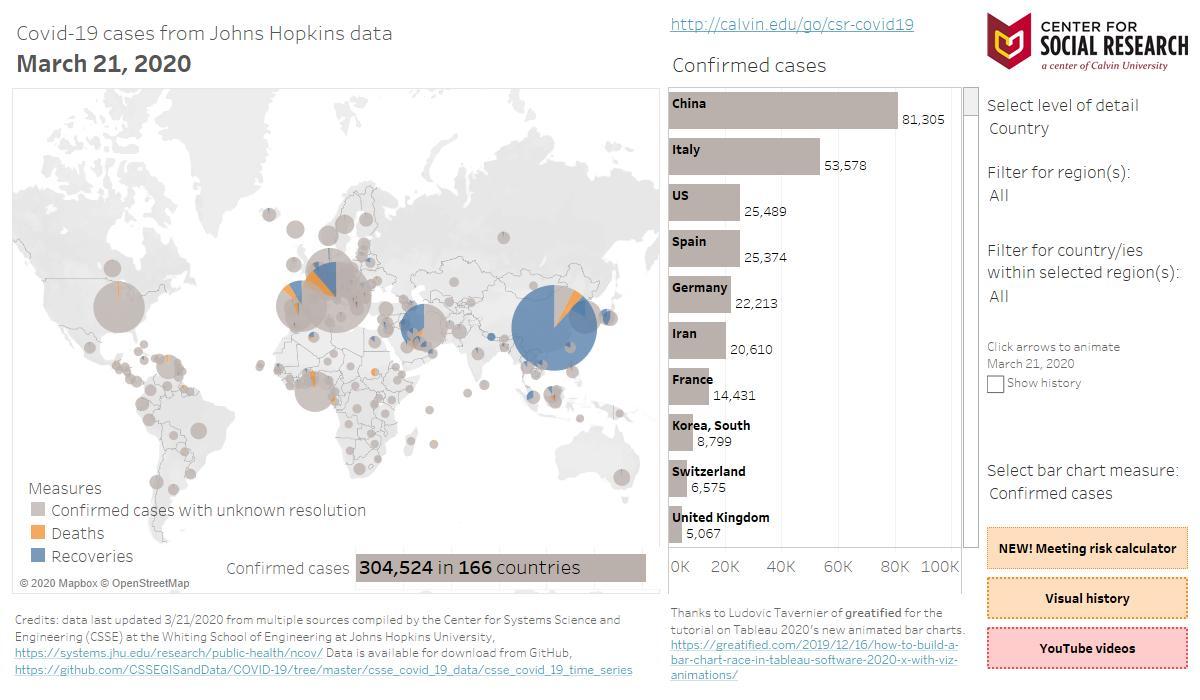Identify some key points in this picture. Italy has the second highest number of confirmed cases. The number of confirmed cases in China is significantly higher than Italy, with a difference of 27,727. China and Italy are countries that have more than 50,000 confirmed cases of COVID-19. The color blue, white, or yellow is used to represent deaths on a map. Yellow is the color commonly used for this purpose. The United States and Spain have confirmed cases of COVID-19 between 25,000 and 50,000, based on the latest data. 